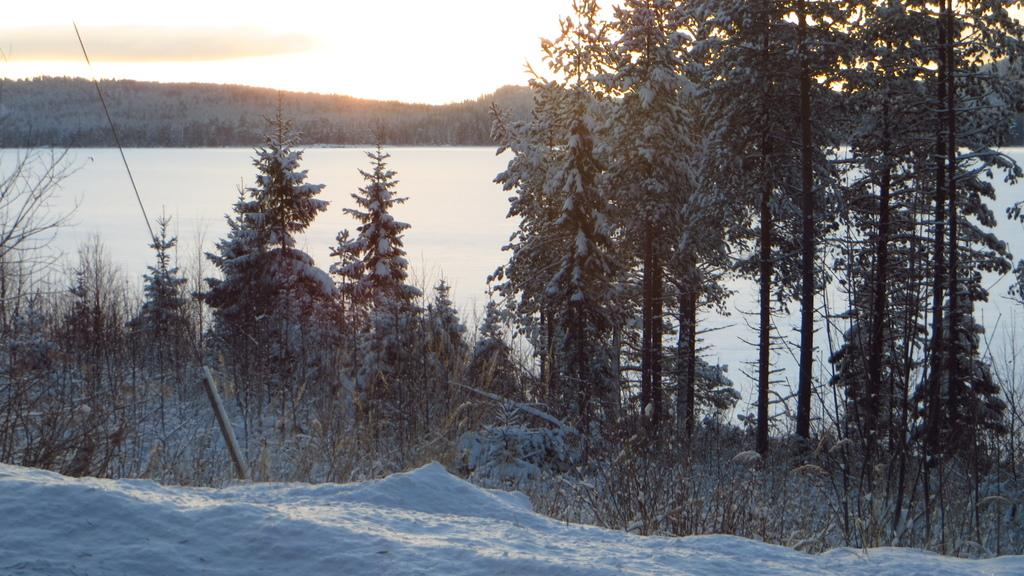What is the primary weather condition depicted in the image? There is snow in the image. How do the trees appear in the image? The trees are covered by snow in the image. What can be seen in the background of the image? There is sky visible in the background of the image. What type of brass instrument can be heard playing in the image? There is no brass instrument or sound present in the image, as it is a still image of snow-covered trees and sky. 